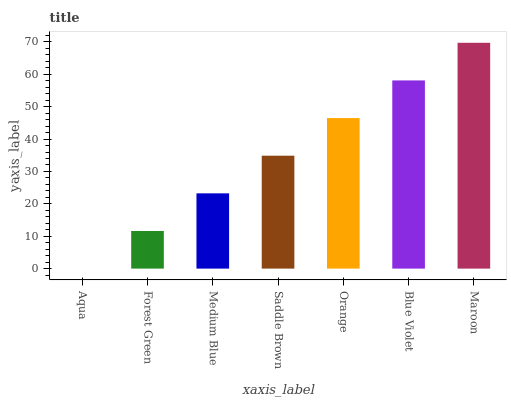Is Aqua the minimum?
Answer yes or no. Yes. Is Maroon the maximum?
Answer yes or no. Yes. Is Forest Green the minimum?
Answer yes or no. No. Is Forest Green the maximum?
Answer yes or no. No. Is Forest Green greater than Aqua?
Answer yes or no. Yes. Is Aqua less than Forest Green?
Answer yes or no. Yes. Is Aqua greater than Forest Green?
Answer yes or no. No. Is Forest Green less than Aqua?
Answer yes or no. No. Is Saddle Brown the high median?
Answer yes or no. Yes. Is Saddle Brown the low median?
Answer yes or no. Yes. Is Forest Green the high median?
Answer yes or no. No. Is Forest Green the low median?
Answer yes or no. No. 